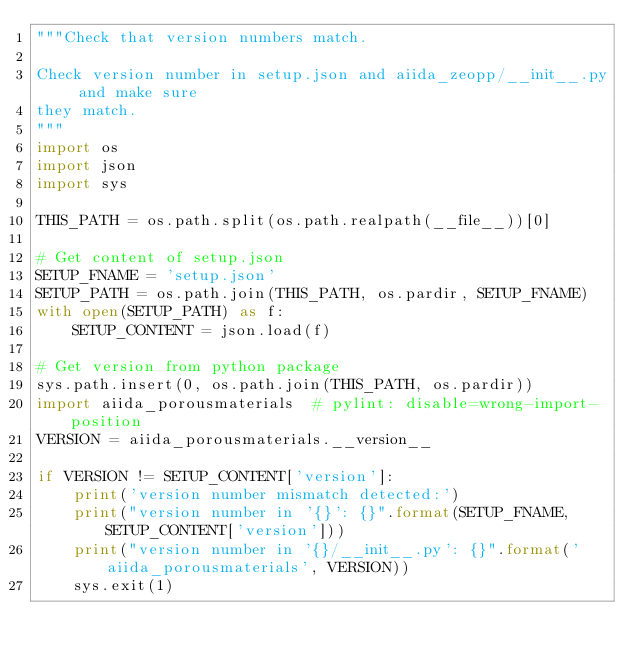Convert code to text. <code><loc_0><loc_0><loc_500><loc_500><_Python_>"""Check that version numbers match.

Check version number in setup.json and aiida_zeopp/__init__.py and make sure
they match.
"""
import os
import json
import sys

THIS_PATH = os.path.split(os.path.realpath(__file__))[0]

# Get content of setup.json
SETUP_FNAME = 'setup.json'
SETUP_PATH = os.path.join(THIS_PATH, os.pardir, SETUP_FNAME)
with open(SETUP_PATH) as f:
    SETUP_CONTENT = json.load(f)

# Get version from python package
sys.path.insert(0, os.path.join(THIS_PATH, os.pardir))
import aiida_porousmaterials  # pylint: disable=wrong-import-position
VERSION = aiida_porousmaterials.__version__

if VERSION != SETUP_CONTENT['version']:
    print('version number mismatch detected:')
    print("version number in '{}': {}".format(SETUP_FNAME, SETUP_CONTENT['version']))
    print("version number in '{}/__init__.py': {}".format('aiida_porousmaterials', VERSION))
    sys.exit(1)
</code> 